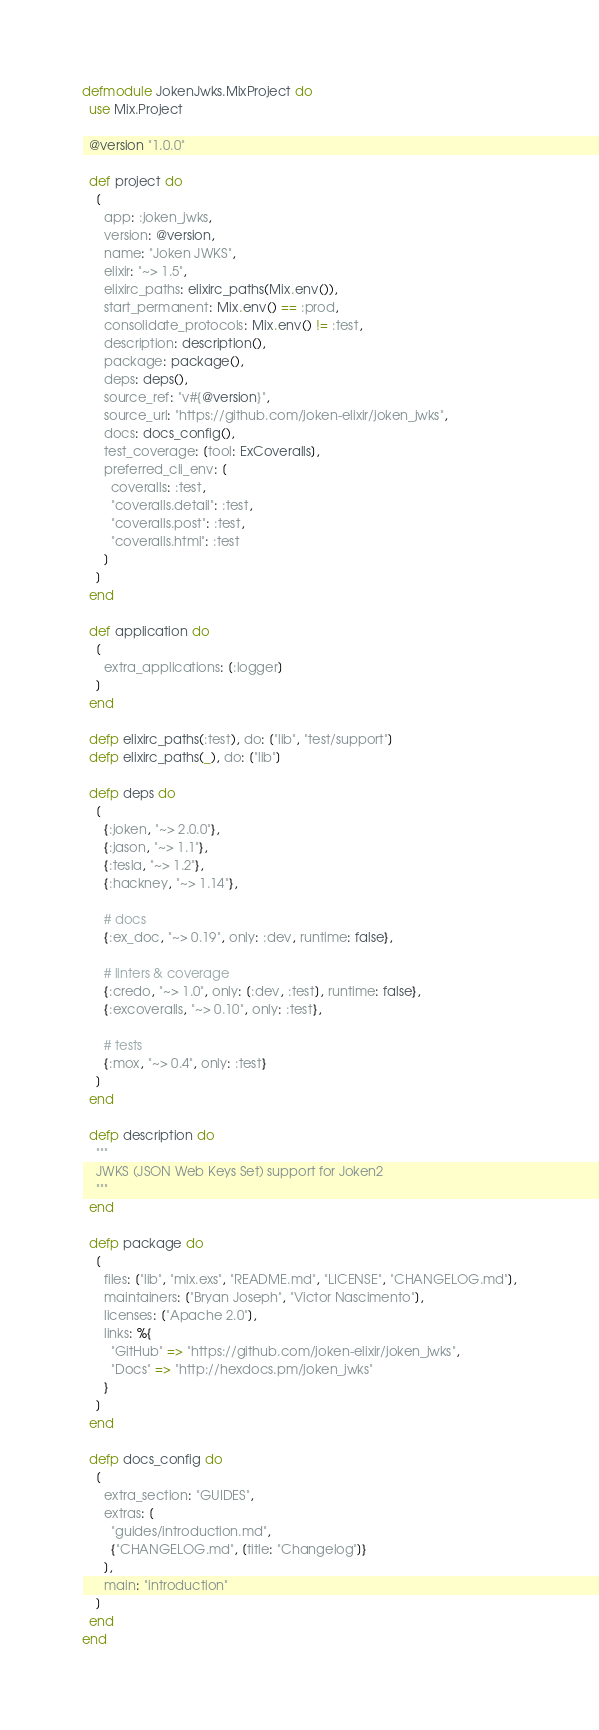<code> <loc_0><loc_0><loc_500><loc_500><_Elixir_>defmodule JokenJwks.MixProject do
  use Mix.Project

  @version "1.0.0"

  def project do
    [
      app: :joken_jwks,
      version: @version,
      name: "Joken JWKS",
      elixir: "~> 1.5",
      elixirc_paths: elixirc_paths(Mix.env()),
      start_permanent: Mix.env() == :prod,
      consolidate_protocols: Mix.env() != :test,
      description: description(),
      package: package(),
      deps: deps(),
      source_ref: "v#{@version}",
      source_url: "https://github.com/joken-elixir/joken_jwks",
      docs: docs_config(),
      test_coverage: [tool: ExCoveralls],
      preferred_cli_env: [
        coveralls: :test,
        "coveralls.detail": :test,
        "coveralls.post": :test,
        "coveralls.html": :test
      ]
    ]
  end

  def application do
    [
      extra_applications: [:logger]
    ]
  end

  defp elixirc_paths(:test), do: ["lib", "test/support"]
  defp elixirc_paths(_), do: ["lib"]

  defp deps do
    [
      {:joken, "~> 2.0.0"},
      {:jason, "~> 1.1"},
      {:tesla, "~> 1.2"},
      {:hackney, "~> 1.14"},

      # docs
      {:ex_doc, "~> 0.19", only: :dev, runtime: false},

      # linters & coverage
      {:credo, "~> 1.0", only: [:dev, :test], runtime: false},
      {:excoveralls, "~> 0.10", only: :test},

      # tests
      {:mox, "~> 0.4", only: :test}
    ]
  end

  defp description do
    """
    JWKS (JSON Web Keys Set) support for Joken2
    """
  end

  defp package do
    [
      files: ["lib", "mix.exs", "README.md", "LICENSE", "CHANGELOG.md"],
      maintainers: ["Bryan Joseph", "Victor Nascimento"],
      licenses: ["Apache 2.0"],
      links: %{
        "GitHub" => "https://github.com/joken-elixir/joken_jwks",
        "Docs" => "http://hexdocs.pm/joken_jwks"
      }
    ]
  end

  defp docs_config do
    [
      extra_section: "GUIDES",
      extras: [
        "guides/introduction.md",
        {"CHANGELOG.md", [title: "Changelog"]}
      ],
      main: "introduction"
    ]
  end
end
</code> 